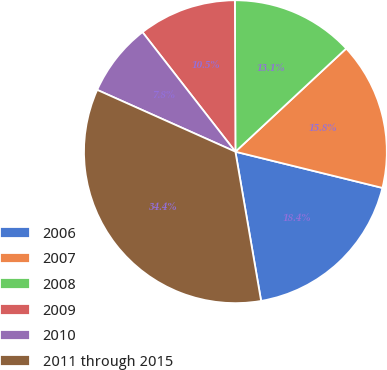Convert chart to OTSL. <chart><loc_0><loc_0><loc_500><loc_500><pie_chart><fcel>2006<fcel>2007<fcel>2008<fcel>2009<fcel>2010<fcel>2011 through 2015<nl><fcel>18.44%<fcel>15.78%<fcel>13.12%<fcel>10.46%<fcel>7.79%<fcel>34.41%<nl></chart> 